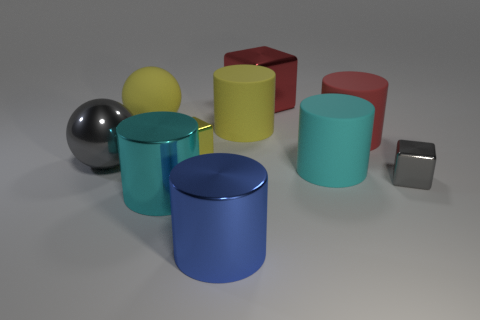Does the large cyan thing that is behind the small gray block have the same shape as the small gray metallic object?
Offer a very short reply. No. What number of matte things are behind the tiny yellow object and on the right side of the large red metal object?
Provide a short and direct response. 1. There is a tiny block that is left of the big metallic thing that is behind the large yellow rubber thing that is on the left side of the big blue cylinder; what is its color?
Offer a terse response. Yellow. There is a big cyan cylinder that is behind the tiny gray shiny block; what number of large blue shiny objects are left of it?
Offer a terse response. 1. What number of other objects are the same shape as the tiny gray metallic thing?
Your answer should be very brief. 2. What number of things are blue blocks or big metallic objects behind the small yellow metal cube?
Offer a terse response. 1. Is the number of gray blocks left of the yellow rubber cylinder greater than the number of red shiny cubes that are on the left side of the gray ball?
Provide a short and direct response. No. What shape is the gray metallic thing to the left of the large rubber thing that is left of the large cyan object left of the large yellow matte cylinder?
Provide a succinct answer. Sphere. There is a blue thing that is in front of the sphere in front of the large red matte object; what is its shape?
Offer a very short reply. Cylinder. Is there a tiny purple ball that has the same material as the gray block?
Ensure brevity in your answer.  No. 